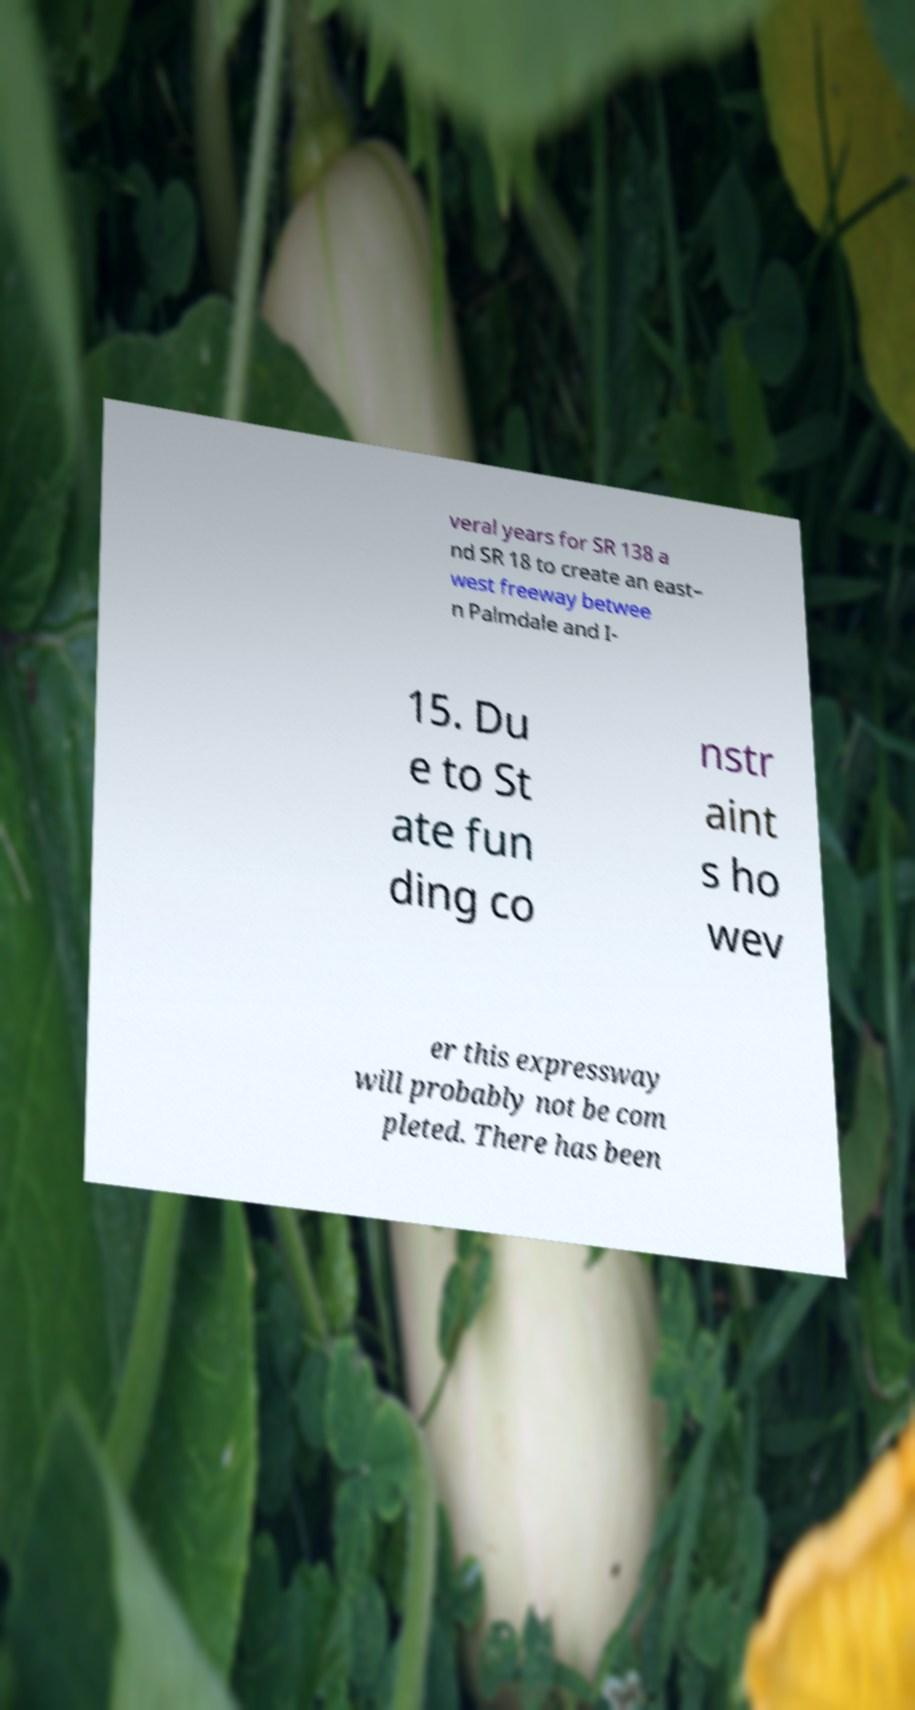For documentation purposes, I need the text within this image transcribed. Could you provide that? veral years for SR 138 a nd SR 18 to create an east– west freeway betwee n Palmdale and I- 15. Du e to St ate fun ding co nstr aint s ho wev er this expressway will probably not be com pleted. There has been 